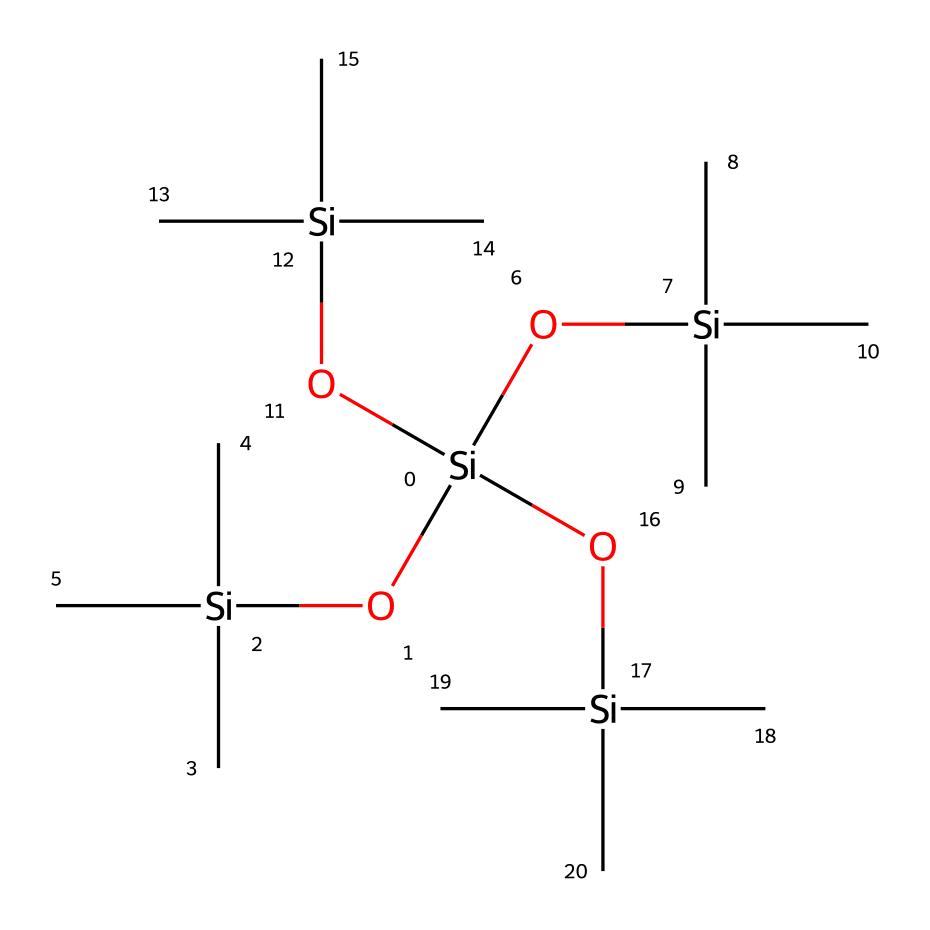What is the main element in this organosilicon compound? The SMILES representation shows silicon atoms denoted by "Si." Since silicone-based products are primarily composed of silicon, the main element is silicon.
Answer: silicon How many silicon atoms are present in this structure? By analyzing the SMILES notation, there are five "Si" symbols, indicating five silicon atoms present in the compound.
Answer: five What type of bonds are predominantly present in this chemical? The structure primarily exhibits Si-O (silicon-oxygen) bonds, as suggested by the "O" connected to "Si" in the SMILES pattern, indicating the presence of siloxane linkages.
Answer: siloxane bonds What functional groups can be identified in this compound? The repetition of the -O[Si](C)(C)C units reflects the presence of silanol (Si-OH) and siloxane (Si-O-Si) functional groups throughout the structure.
Answer: silanol and siloxane Is this compound likely to be hydrophobic or hydrophilic? Given the dominance of silicon-oxygen bonds and the silicone structure, which typically leads to lower polarity, the compound is likely to be hydrophobic.
Answer: hydrophobic How might this chemical structure affect the texture of hair products? The branching structure and high silicon content suggest that this compound provides smoothness and reduces friction, enhancing the texture of hair products and leading to a silky feel.
Answer: smoothness What is the significance of the branched structure observed in the SMILES? The branched design contributes to the flexibility and compatibility of the compound, allowing it to spread evenly on hair, which is essential for even coverage in hair treatments.
Answer: flexibility 